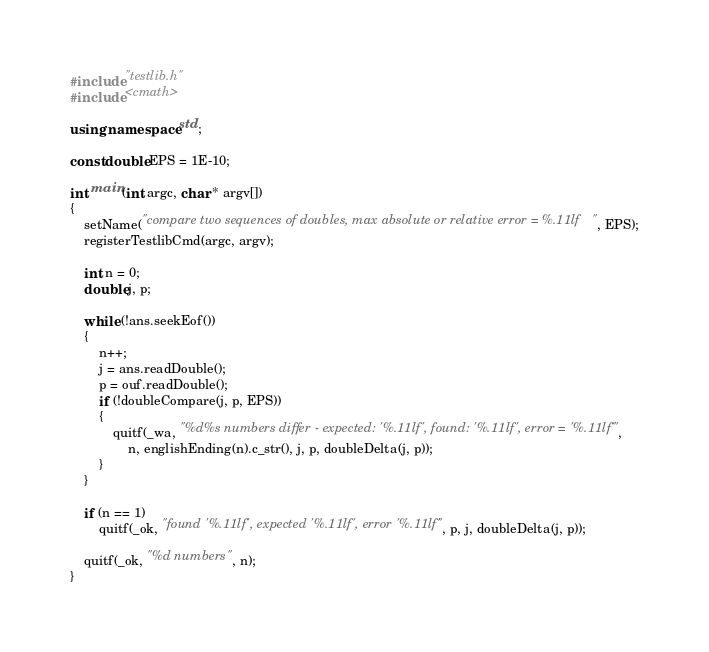<code> <loc_0><loc_0><loc_500><loc_500><_C++_>#include "testlib.h"
#include <cmath>

using namespace std;

const double EPS = 1E-10;

int main(int argc, char * argv[])
{
    setName("compare two sequences of doubles, max absolute or relative error = %.11lf", EPS);
    registerTestlibCmd(argc, argv);

    int n = 0;
    double j, p;

    while (!ans.seekEof()) 
    {
        n++;
        j = ans.readDouble();
        p = ouf.readDouble();
        if (!doubleCompare(j, p, EPS))
        {
            quitf(_wa, "%d%s numbers differ - expected: '%.11lf', found: '%.11lf', error = '%.11lf'",
                n, englishEnding(n).c_str(), j, p, doubleDelta(j, p));
        }
    }

    if (n == 1)
        quitf(_ok, "found '%.11lf', expected '%.11lf', error '%.11lf'", p, j, doubleDelta(j, p));

    quitf(_ok, "%d numbers", n);
}
</code> 